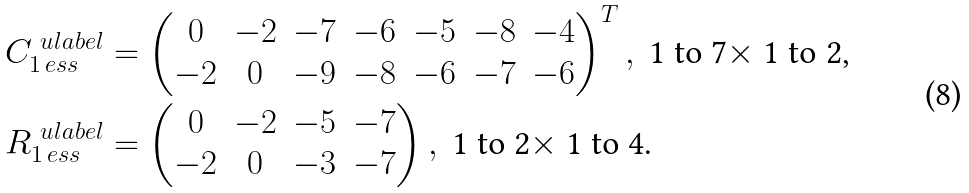<formula> <loc_0><loc_0><loc_500><loc_500>C _ { 1 \, e s s } ^ { \ u l a b e l } & = \begin{pmatrix} 0 & - 2 & - 7 & - 6 & - 5 & - 8 & - 4 \\ - 2 & 0 & - 9 & - 8 & - 6 & - 7 & - 6 \end{pmatrix} ^ { T } , \ \text {1 to 7$\times$ 1 to 2,} \\ R _ { 1 \, e s s } ^ { \ u l a b e l } & = \begin{pmatrix} 0 & - 2 & - 5 & - 7 \\ - 2 & 0 & - 3 & - 7 \end{pmatrix} , \ \text {1 to 2$\times$ 1 to 4.} \\</formula> 